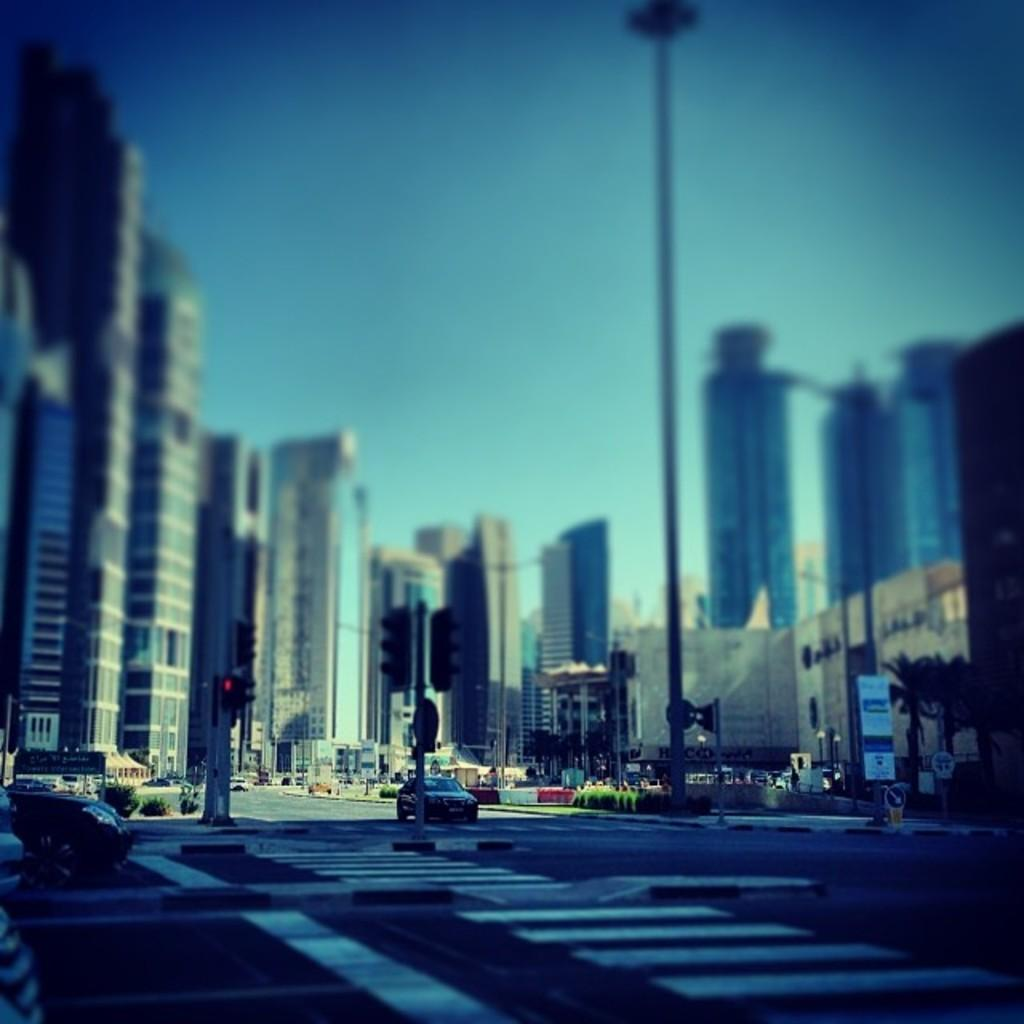What can be seen in the sky in the image? The sky is visible in the image, but no specific details about the sky are mentioned in the facts. What type of structures are present in the image? There are buildings in the image. What type of signs can be seen in the image? Sign boards are present in the image. What type of vegetation is present in the image? Trees and shrubs are visible in the image. What type of infrastructure is present in the image? Traffic poles and traffic signals are present in the image. What type of transportation is visible in the image? Motor vehicles are on the road in the image. What type of jar is visible on the traffic signal in the image? There is no jar present on the traffic signal in the image. What type of lamp is hanging from the trees in the image? There are no lamps hanging from the trees in the image. 